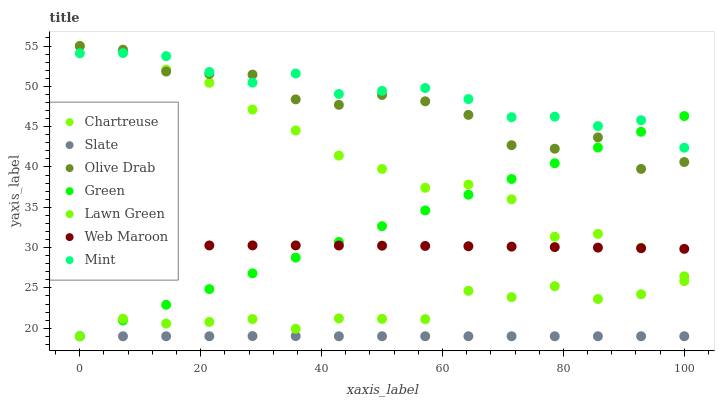Does Slate have the minimum area under the curve?
Answer yes or no. Yes. Does Mint have the maximum area under the curve?
Answer yes or no. Yes. Does Web Maroon have the minimum area under the curve?
Answer yes or no. No. Does Web Maroon have the maximum area under the curve?
Answer yes or no. No. Is Green the smoothest?
Answer yes or no. Yes. Is Olive Drab the roughest?
Answer yes or no. Yes. Is Slate the smoothest?
Answer yes or no. No. Is Slate the roughest?
Answer yes or no. No. Does Lawn Green have the lowest value?
Answer yes or no. Yes. Does Web Maroon have the lowest value?
Answer yes or no. No. Does Olive Drab have the highest value?
Answer yes or no. Yes. Does Web Maroon have the highest value?
Answer yes or no. No. Is Slate less than Chartreuse?
Answer yes or no. Yes. Is Web Maroon greater than Slate?
Answer yes or no. Yes. Does Green intersect Web Maroon?
Answer yes or no. Yes. Is Green less than Web Maroon?
Answer yes or no. No. Is Green greater than Web Maroon?
Answer yes or no. No. Does Slate intersect Chartreuse?
Answer yes or no. No. 